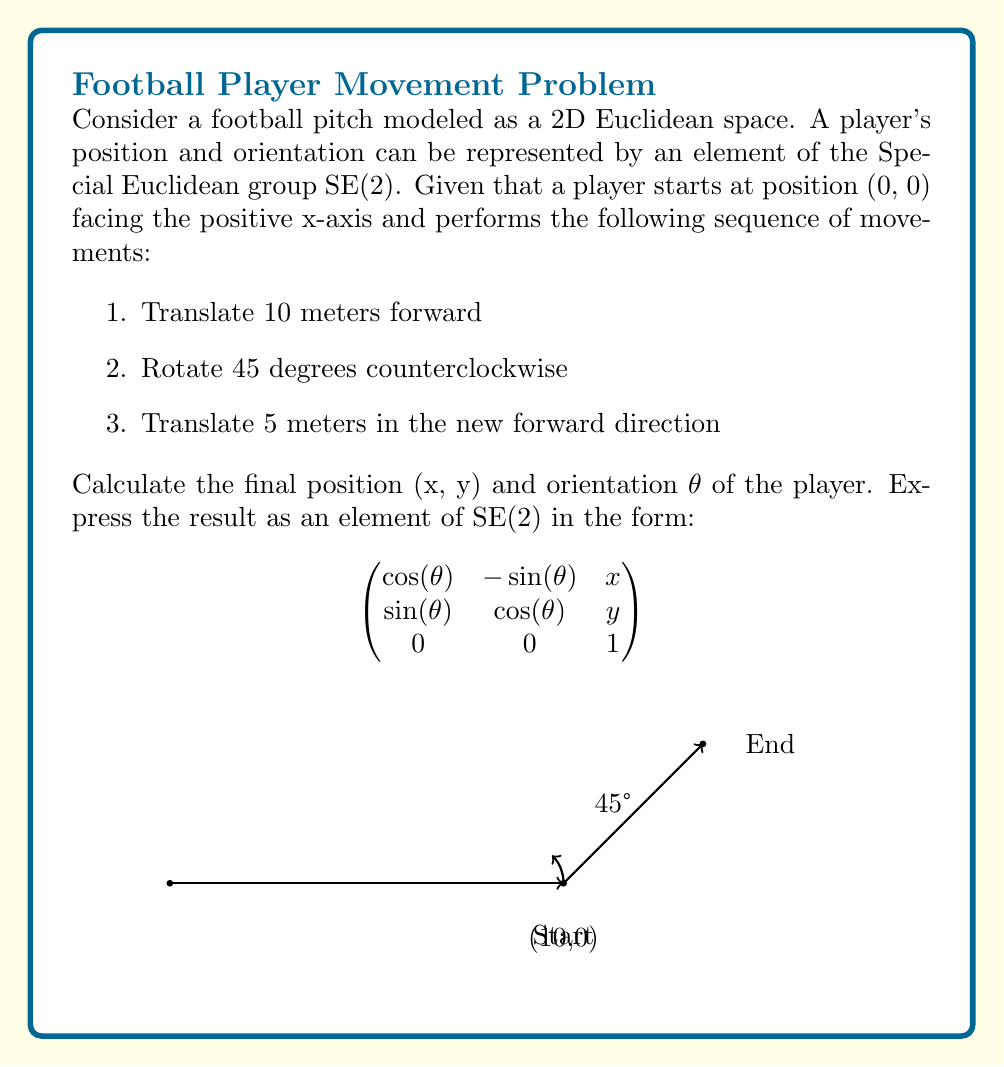Help me with this question. Let's approach this step-by-step using the properties of SE(2):

1) The initial position is represented by the identity matrix:

   $$ A_0 = \begin{pmatrix} 
   1 & 0 & 0 \\
   0 & 1 & 0 \\
   0 & 0 & 1
   \end{pmatrix} $$

2) The first translation of 10 meters forward is represented by:

   $$ T_1 = \begin{pmatrix} 
   1 & 0 & 10 \\
   0 & 1 & 0 \\
   0 & 0 & 1
   \end{pmatrix} $$

3) The rotation of 45 degrees (π/4 radians) counterclockwise is represented by:

   $$ R = \begin{pmatrix} 
   \cos(\pi/4) & -\sin(\pi/4) & 0 \\
   \sin(\pi/4) & \cos(\pi/4) & 0 \\
   0 & 0 & 1
   \end{pmatrix} = \begin{pmatrix} 
   \frac{\sqrt{2}}{2} & -\frac{\sqrt{2}}{2} & 0 \\
   \frac{\sqrt{2}}{2} & \frac{\sqrt{2}}{2} & 0 \\
   0 & 0 & 1
   \end{pmatrix} $$

4) The final translation of 5 meters in the new forward direction is represented by:

   $$ T_2 = \begin{pmatrix} 
   1 & 0 & 5\cos(\pi/4) \\
   0 & 1 & 5\sin(\pi/4) \\
   0 & 0 & 1
   \end{pmatrix} = \begin{pmatrix} 
   1 & 0 & 5\frac{\sqrt{2}}{2} \\
   0 & 1 & 5\frac{\sqrt{2}}{2} \\
   0 & 0 & 1
   \end{pmatrix} $$

5) The final position and orientation is given by the product $T_2 \cdot R \cdot T_1 \cdot A_0$:

   $$ \begin{pmatrix} 
   1 & 0 & 5\frac{\sqrt{2}}{2} \\
   0 & 1 & 5\frac{\sqrt{2}}{2} \\
   0 & 0 & 1
   \end{pmatrix} \cdot
   \begin{pmatrix} 
   \frac{\sqrt{2}}{2} & -\frac{\sqrt{2}}{2} & 0 \\
   \frac{\sqrt{2}}{2} & \frac{\sqrt{2}}{2} & 0 \\
   0 & 0 & 1
   \end{pmatrix} \cdot
   \begin{pmatrix} 
   1 & 0 & 10 \\
   0 & 1 & 0 \\
   0 & 0 & 1
   \end{pmatrix} $$

6) Multiplying these matrices:

   $$ \begin{pmatrix} 
   \frac{\sqrt{2}}{2} & -\frac{\sqrt{2}}{2} & 10 + 5\frac{\sqrt{2}}{2} \\
   \frac{\sqrt{2}}{2} & \frac{\sqrt{2}}{2} & 5\frac{\sqrt{2}}{2} \\
   0 & 0 & 1
   \end{pmatrix} $$

7) Therefore, the final position is $(10 + 5\frac{\sqrt{2}}{2}, 5\frac{\sqrt{2}}{2})$ and the final orientation is 45° (π/4 radians).
Answer: $$ \begin{pmatrix} 
\frac{\sqrt{2}}{2} & -\frac{\sqrt{2}}{2} & 10 + 5\frac{\sqrt{2}}{2} \\
\frac{\sqrt{2}}{2} & \frac{\sqrt{2}}{2} & 5\frac{\sqrt{2}}{2} \\
0 & 0 & 1
\end{pmatrix} $$ 